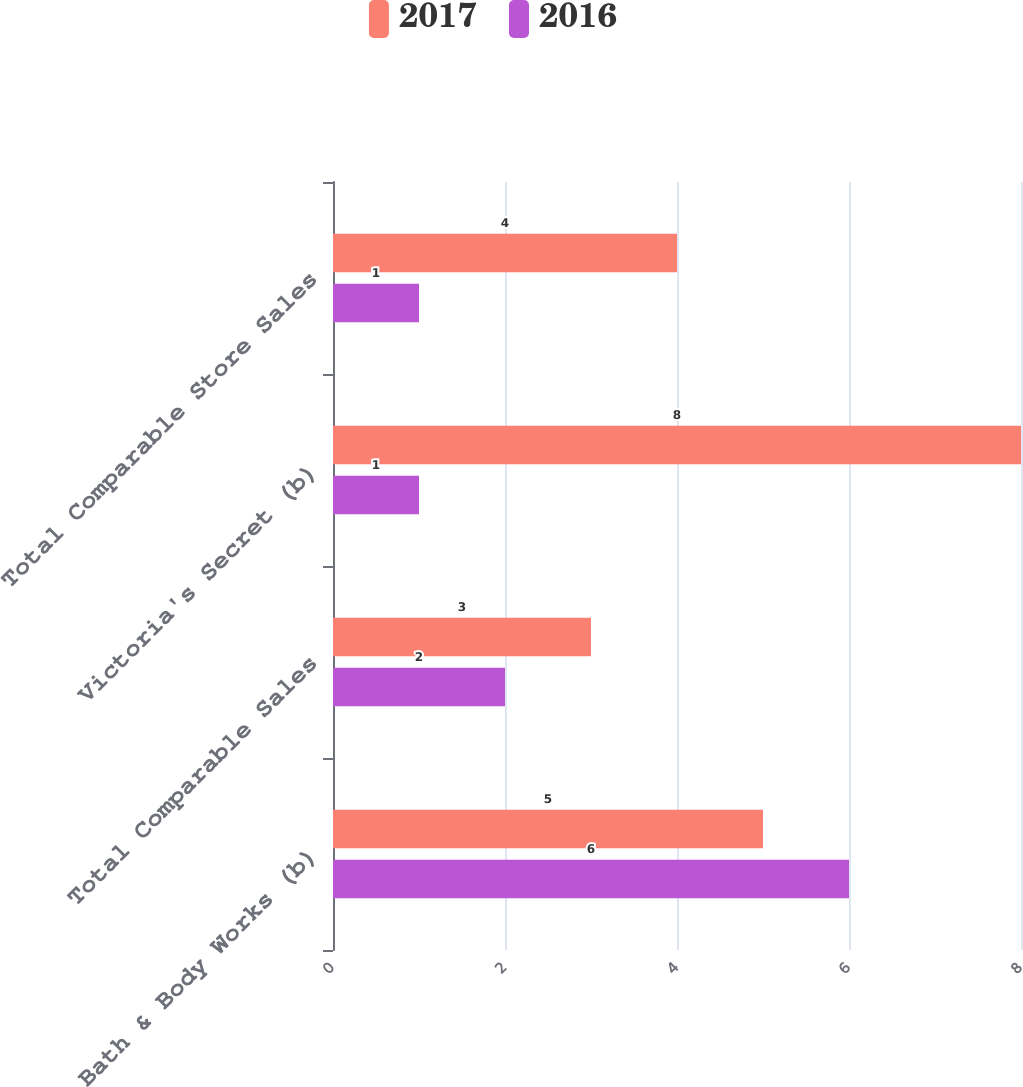Convert chart to OTSL. <chart><loc_0><loc_0><loc_500><loc_500><stacked_bar_chart><ecel><fcel>Bath & Body Works (b)<fcel>Total Comparable Sales<fcel>Victoria's Secret (b)<fcel>Total Comparable Store Sales<nl><fcel>2017<fcel>5<fcel>3<fcel>8<fcel>4<nl><fcel>2016<fcel>6<fcel>2<fcel>1<fcel>1<nl></chart> 